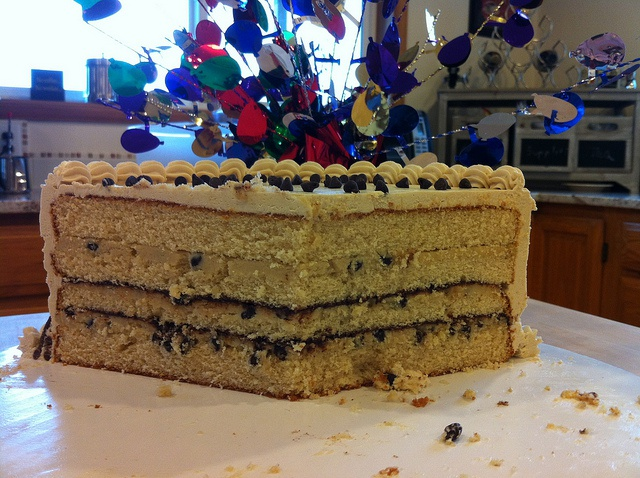Describe the objects in this image and their specific colors. I can see cake in white, olive, gray, and black tones, dining table in white, tan, darkgray, and lightgray tones, and oven in white, black, gray, and navy tones in this image. 